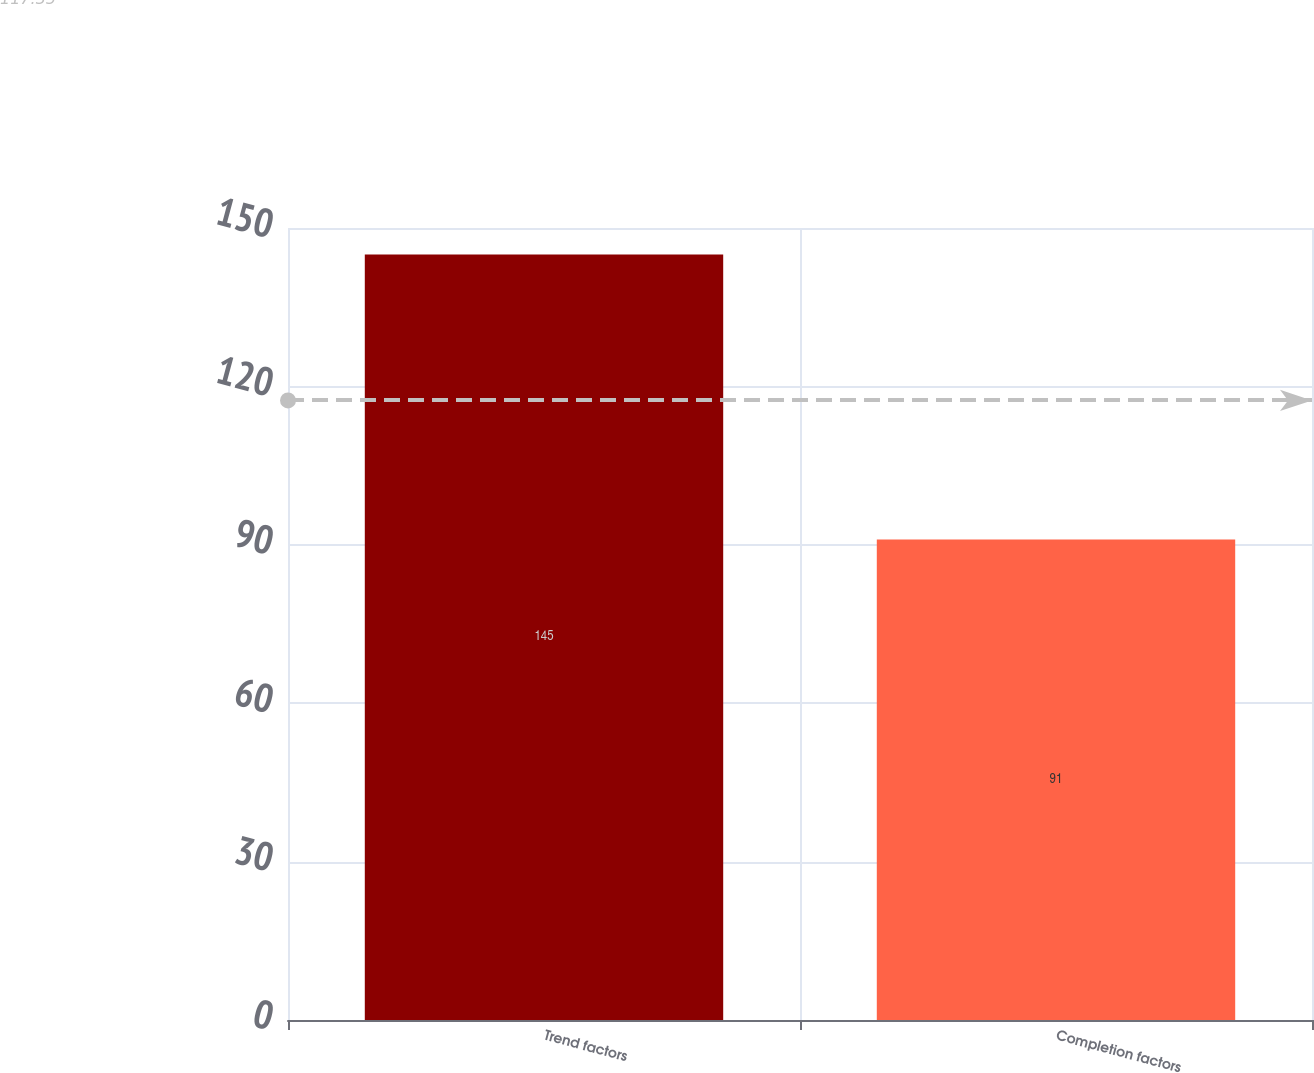Convert chart. <chart><loc_0><loc_0><loc_500><loc_500><bar_chart><fcel>Trend factors<fcel>Completion factors<nl><fcel>145<fcel>91<nl></chart> 